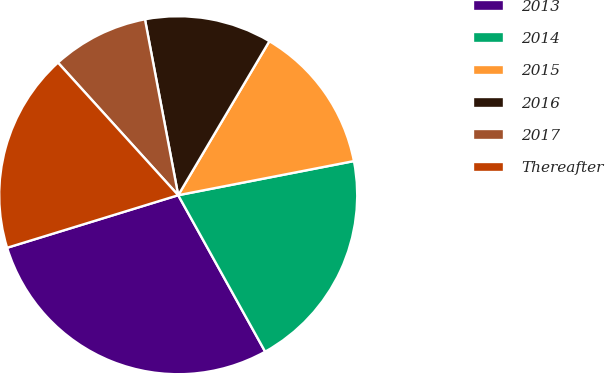Convert chart to OTSL. <chart><loc_0><loc_0><loc_500><loc_500><pie_chart><fcel>2013<fcel>2014<fcel>2015<fcel>2016<fcel>2017<fcel>Thereafter<nl><fcel>28.33%<fcel>19.98%<fcel>13.44%<fcel>11.48%<fcel>8.75%<fcel>18.02%<nl></chart> 